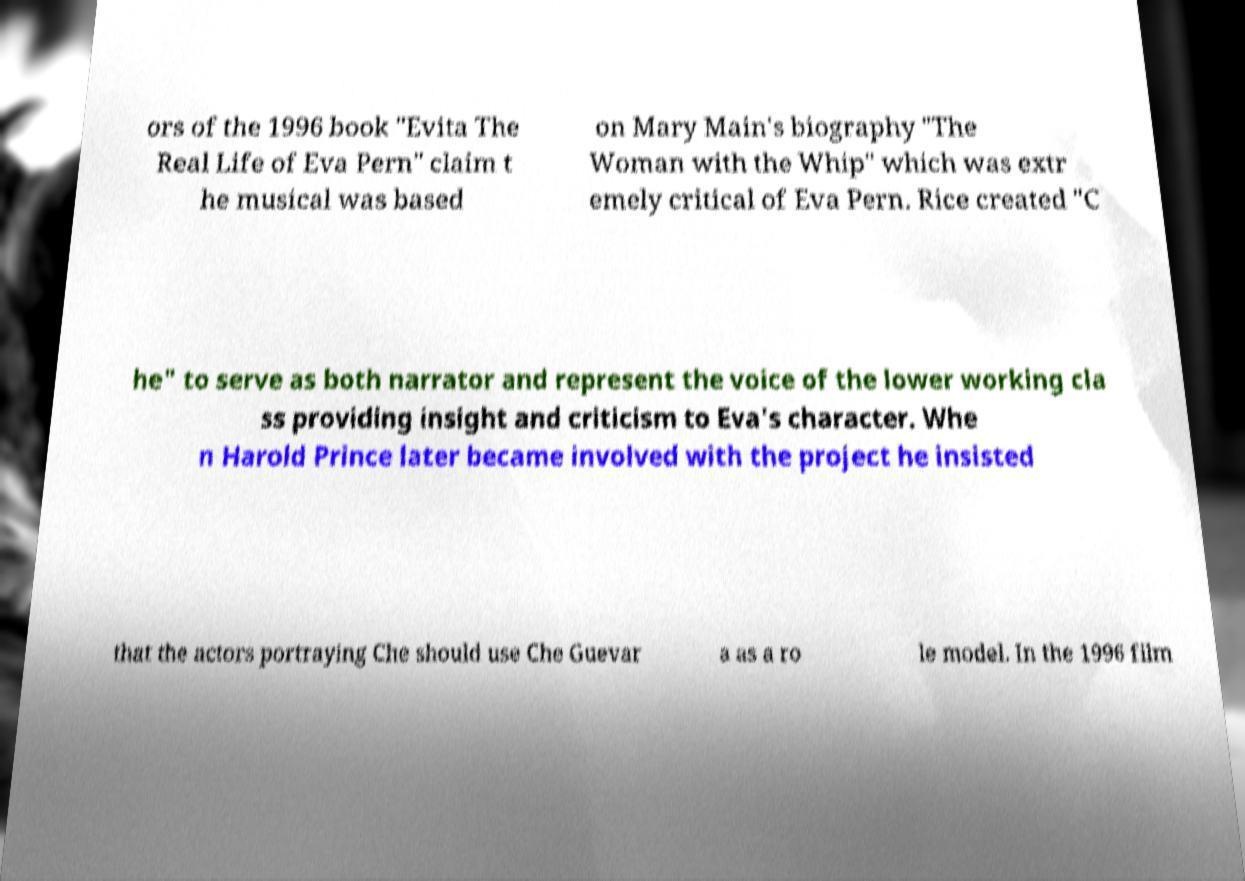Please identify and transcribe the text found in this image. ors of the 1996 book "Evita The Real Life of Eva Pern" claim t he musical was based on Mary Main's biography "The Woman with the Whip" which was extr emely critical of Eva Pern. Rice created "C he" to serve as both narrator and represent the voice of the lower working cla ss providing insight and criticism to Eva's character. Whe n Harold Prince later became involved with the project he insisted that the actors portraying Che should use Che Guevar a as a ro le model. In the 1996 film 